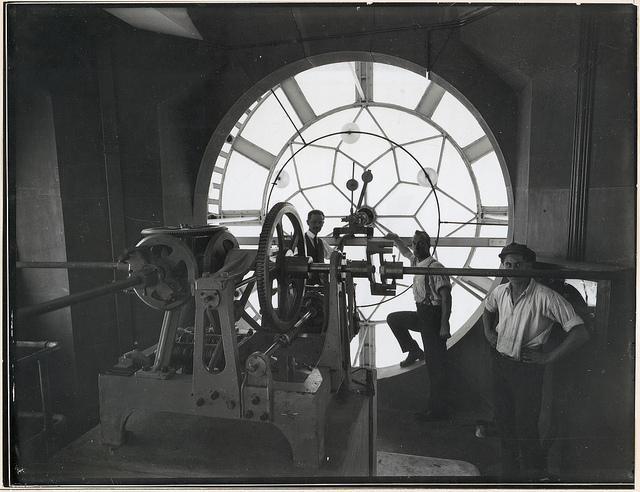How many people can be seen?
Give a very brief answer. 2. 